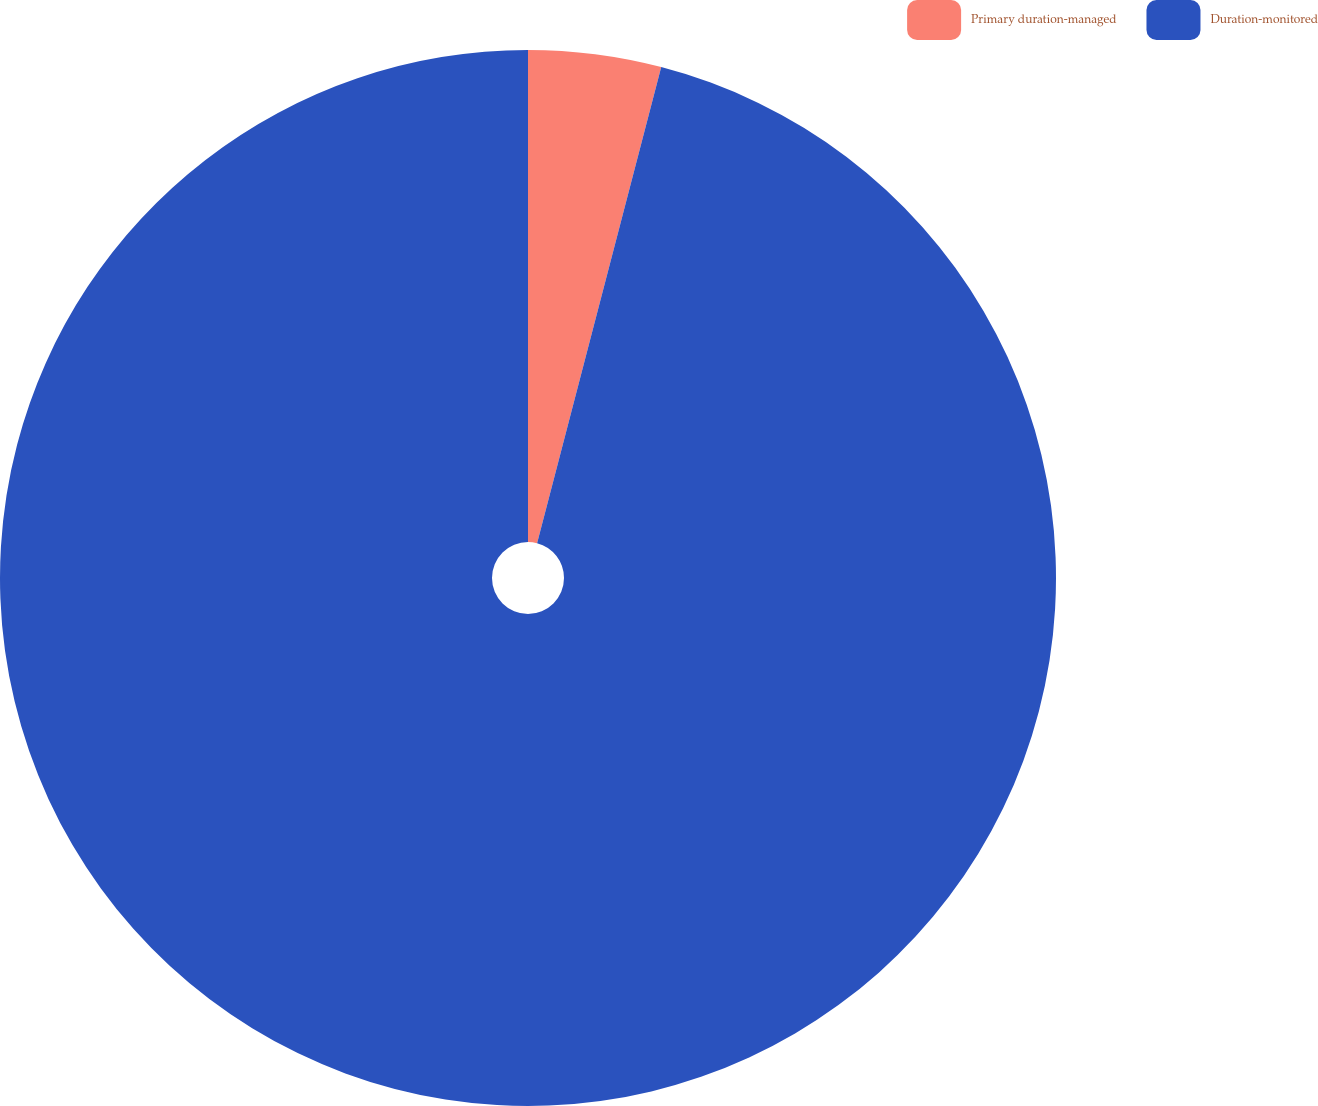Convert chart to OTSL. <chart><loc_0><loc_0><loc_500><loc_500><pie_chart><fcel>Primary duration-managed<fcel>Duration-monitored<nl><fcel>4.06%<fcel>95.94%<nl></chart> 